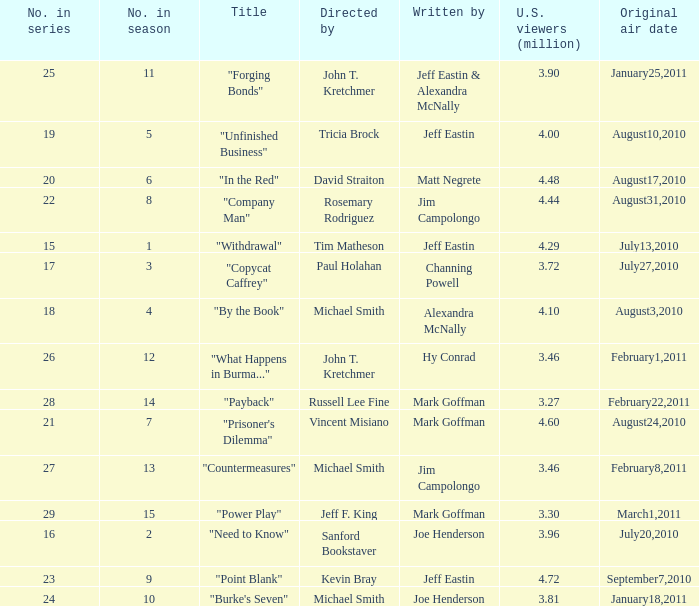How many episodes in the season had 3.81 million US viewers? 1.0. 